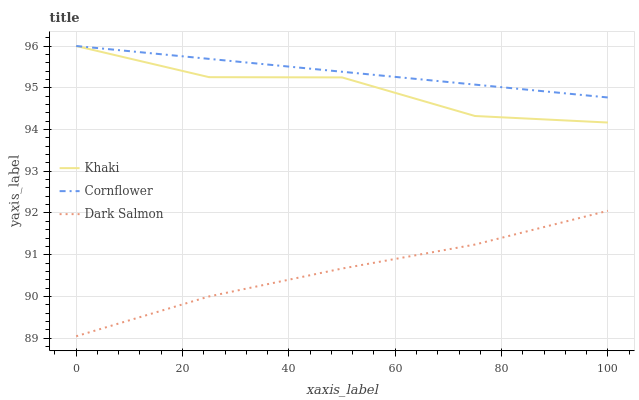Does Dark Salmon have the minimum area under the curve?
Answer yes or no. Yes. Does Cornflower have the maximum area under the curve?
Answer yes or no. Yes. Does Khaki have the minimum area under the curve?
Answer yes or no. No. Does Khaki have the maximum area under the curve?
Answer yes or no. No. Is Cornflower the smoothest?
Answer yes or no. Yes. Is Khaki the roughest?
Answer yes or no. Yes. Is Dark Salmon the smoothest?
Answer yes or no. No. Is Dark Salmon the roughest?
Answer yes or no. No. Does Khaki have the lowest value?
Answer yes or no. No. Does Dark Salmon have the highest value?
Answer yes or no. No. Is Dark Salmon less than Khaki?
Answer yes or no. Yes. Is Cornflower greater than Dark Salmon?
Answer yes or no. Yes. Does Dark Salmon intersect Khaki?
Answer yes or no. No. 